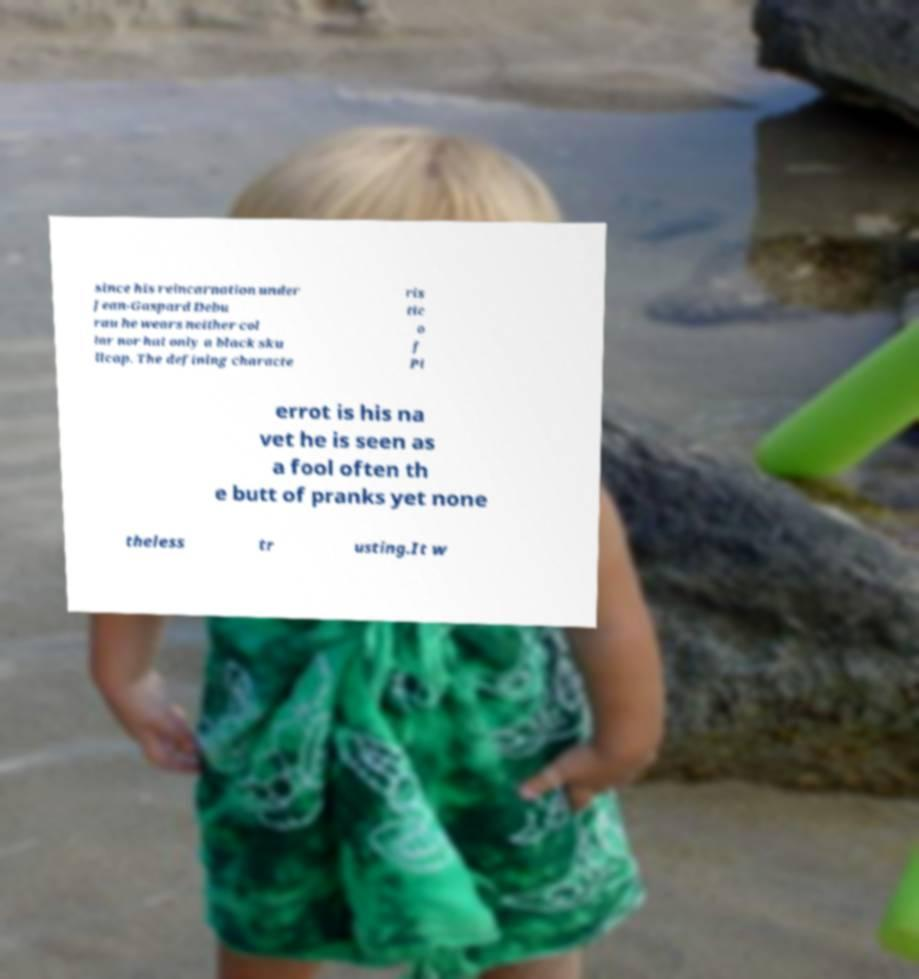Please identify and transcribe the text found in this image. since his reincarnation under Jean-Gaspard Debu rau he wears neither col lar nor hat only a black sku llcap. The defining characte ris tic o f Pi errot is his na vet he is seen as a fool often th e butt of pranks yet none theless tr usting.It w 